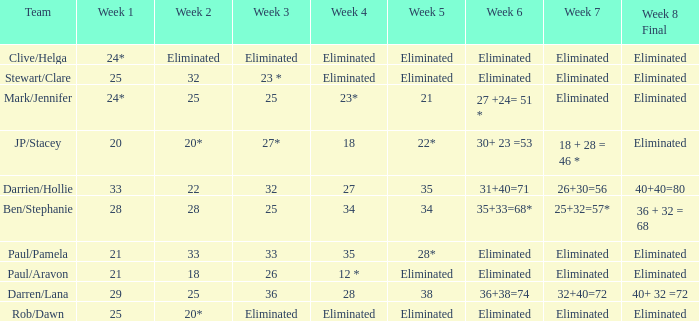Name the week 6 when week 3 is 25 and week 7 is eliminated 27 +24= 51 *. 